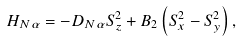Convert formula to latex. <formula><loc_0><loc_0><loc_500><loc_500>H _ { N \alpha } = - D _ { N \alpha } S _ { z } ^ { 2 } + B _ { 2 } \left ( S _ { x } ^ { 2 } - S _ { y } ^ { 2 } \right ) ,</formula> 